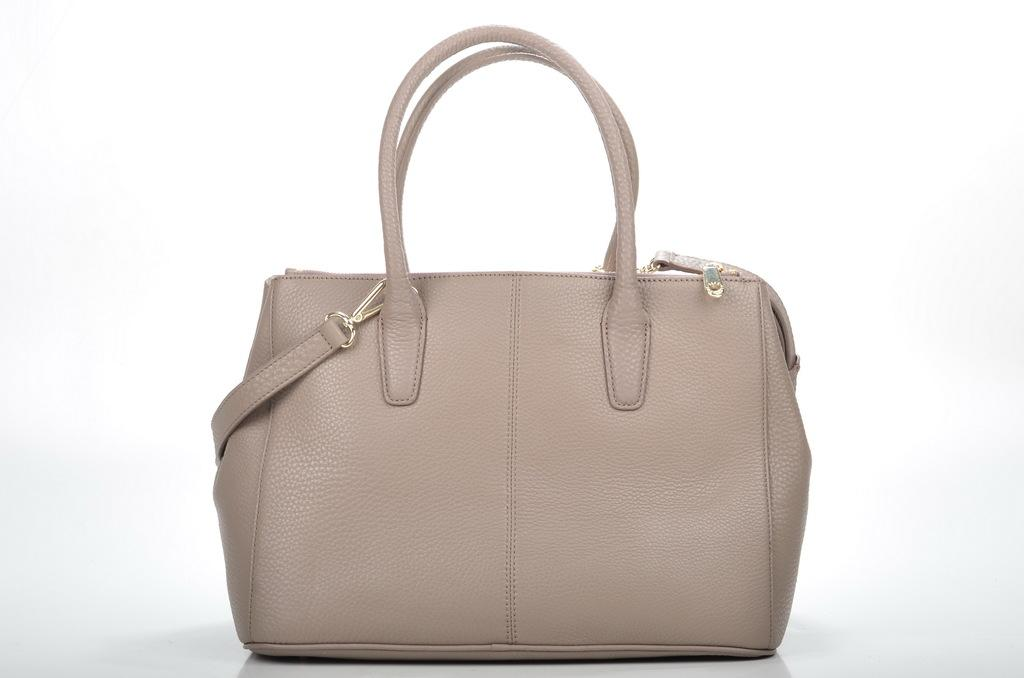What color is the bag in the image? The bag is white in color. What feature does the bag have for securing it? The bag has a belt. How can the bag be carried in the image? The bag has a strap for carrying it. What type of weather is depicted in the image? There is no weather depicted in the image, as it focuses on the bag and its features. 